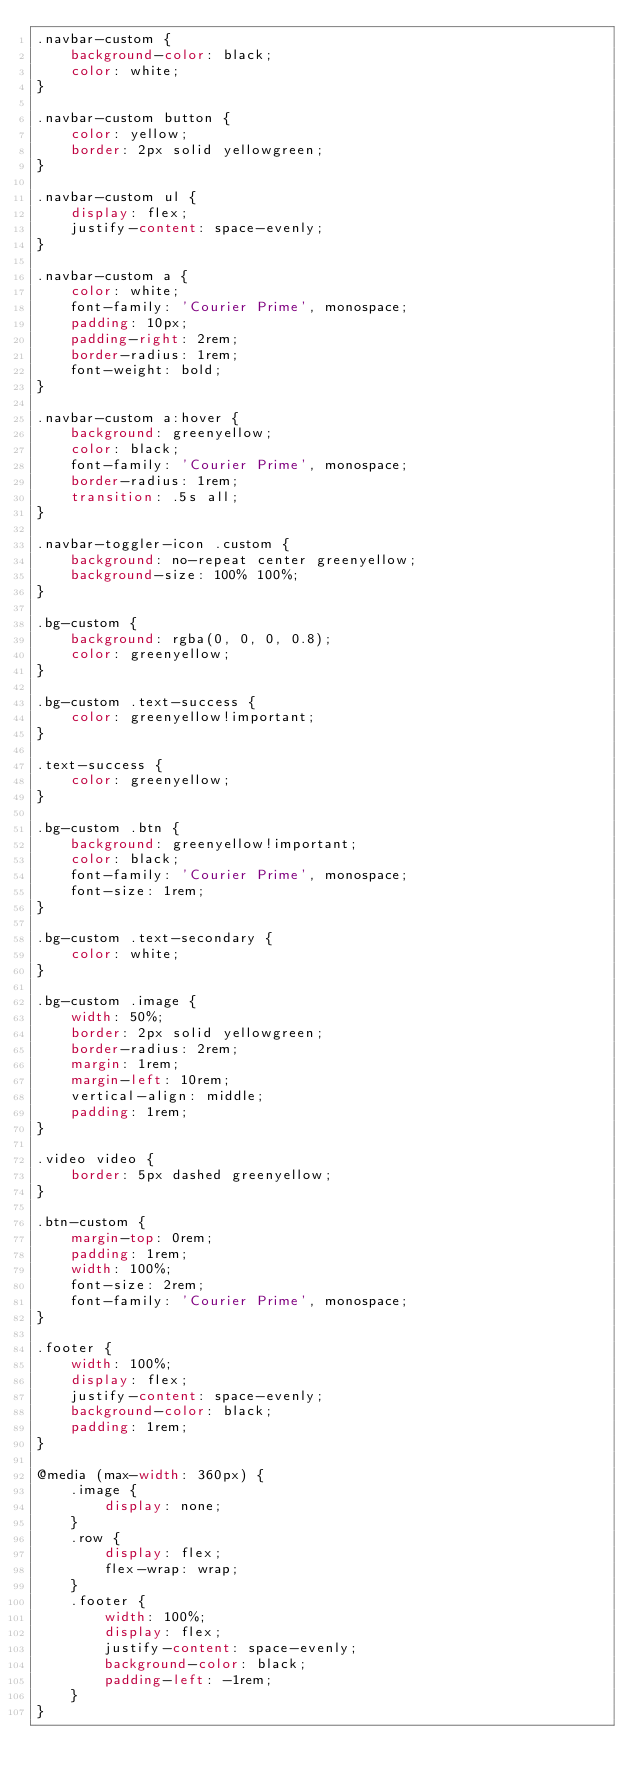Convert code to text. <code><loc_0><loc_0><loc_500><loc_500><_CSS_>.navbar-custom {
    background-color: black;
    color: white;
}

.navbar-custom button {
    color: yellow;
    border: 2px solid yellowgreen;
}

.navbar-custom ul {
    display: flex;
    justify-content: space-evenly;
}

.navbar-custom a {
    color: white;
    font-family: 'Courier Prime', monospace;
    padding: 10px;
    padding-right: 2rem;
    border-radius: 1rem;
    font-weight: bold;
}

.navbar-custom a:hover {
    background: greenyellow;
    color: black;
    font-family: 'Courier Prime', monospace;
    border-radius: 1rem;
    transition: .5s all;
}

.navbar-toggler-icon .custom {
    background: no-repeat center greenyellow;
    background-size: 100% 100%;
}

.bg-custom {
    background: rgba(0, 0, 0, 0.8);
    color: greenyellow;
}

.bg-custom .text-success {
    color: greenyellow!important;
}

.text-success {
    color: greenyellow;
}

.bg-custom .btn {
    background: greenyellow!important;
    color: black;
    font-family: 'Courier Prime', monospace;
    font-size: 1rem;
}

.bg-custom .text-secondary {
    color: white;
}

.bg-custom .image {
    width: 50%;
    border: 2px solid yellowgreen;
    border-radius: 2rem;
    margin: 1rem;
    margin-left: 10rem;
    vertical-align: middle;
    padding: 1rem;
}

.video video {
    border: 5px dashed greenyellow;
}

.btn-custom {
    margin-top: 0rem;
    padding: 1rem;
    width: 100%;
    font-size: 2rem;
    font-family: 'Courier Prime', monospace;
}

.footer {
    width: 100%;
    display: flex;
    justify-content: space-evenly;
    background-color: black;
    padding: 1rem;
}

@media (max-width: 360px) {
    .image {
        display: none;
    }
    .row {
        display: flex;
        flex-wrap: wrap;
    }
    .footer {
        width: 100%;
        display: flex;
        justify-content: space-evenly;
        background-color: black;
        padding-left: -1rem;
    }
}</code> 